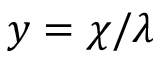<formula> <loc_0><loc_0><loc_500><loc_500>y = \chi / \lambda</formula> 